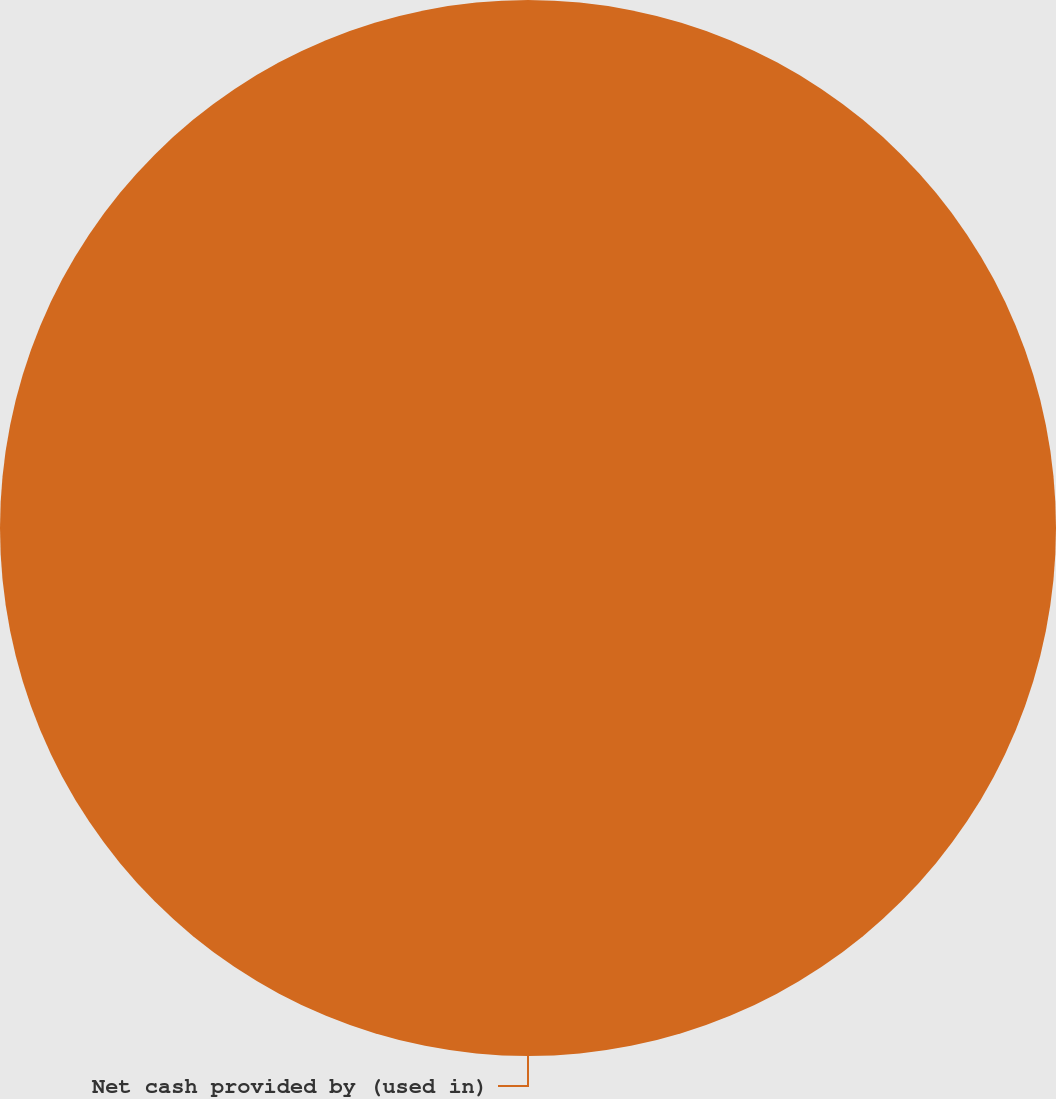Convert chart to OTSL. <chart><loc_0><loc_0><loc_500><loc_500><pie_chart><fcel>Net cash provided by (used in)<nl><fcel>100.0%<nl></chart> 